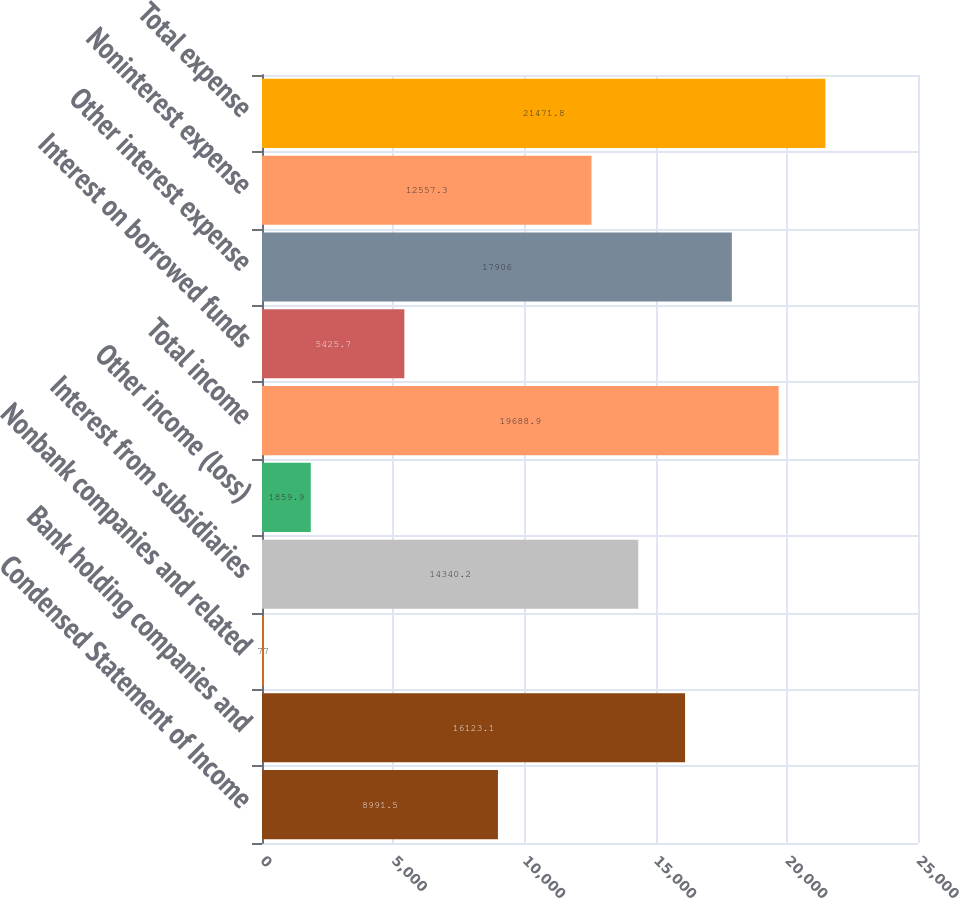<chart> <loc_0><loc_0><loc_500><loc_500><bar_chart><fcel>Condensed Statement of Income<fcel>Bank holding companies and<fcel>Nonbank companies and related<fcel>Interest from subsidiaries<fcel>Other income (loss)<fcel>Total income<fcel>Interest on borrowed funds<fcel>Other interest expense<fcel>Noninterest expense<fcel>Total expense<nl><fcel>8991.5<fcel>16123.1<fcel>77<fcel>14340.2<fcel>1859.9<fcel>19688.9<fcel>5425.7<fcel>17906<fcel>12557.3<fcel>21471.8<nl></chart> 